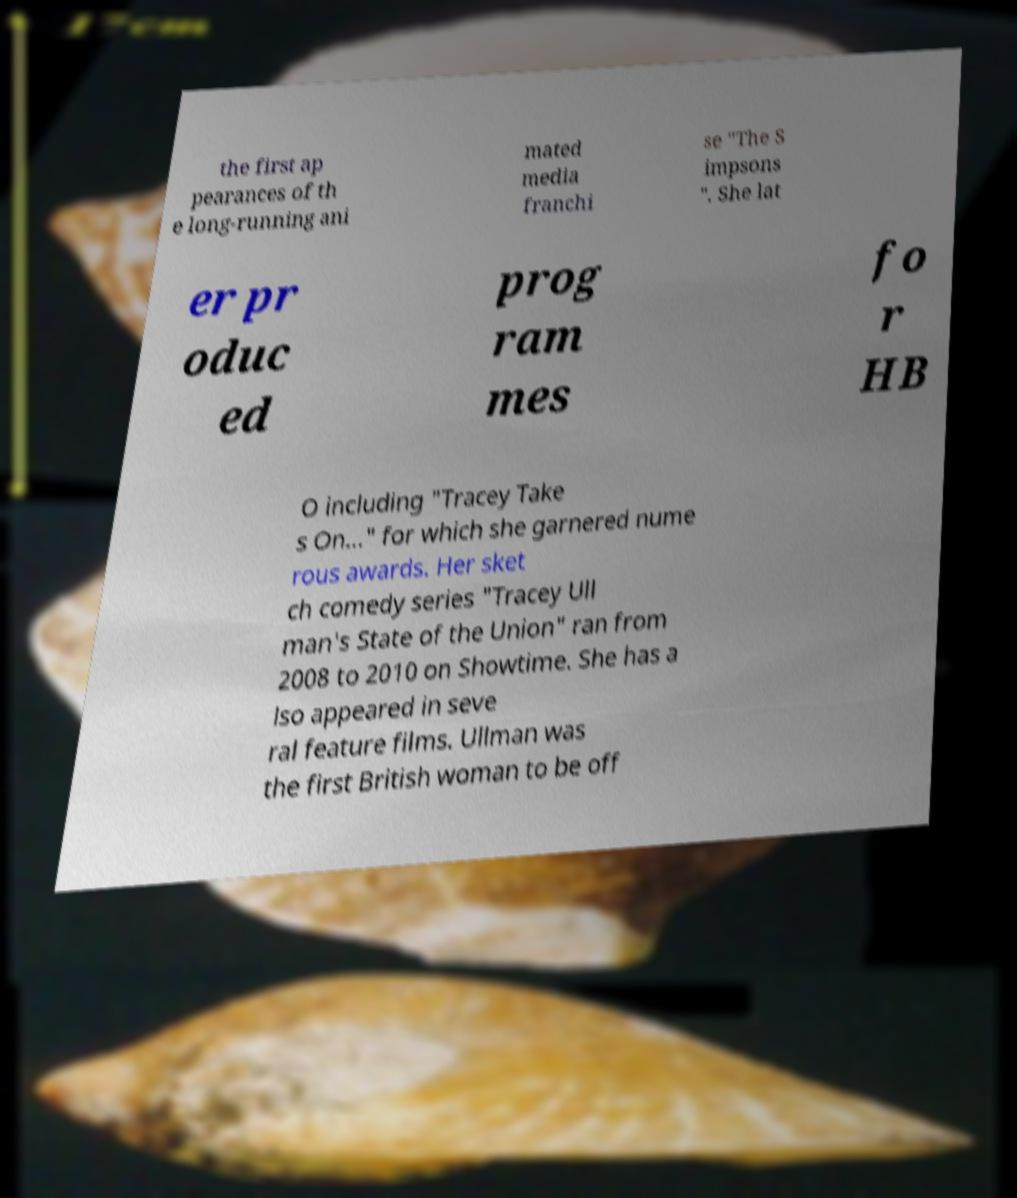What messages or text are displayed in this image? I need them in a readable, typed format. the first ap pearances of th e long-running ani mated media franchi se "The S impsons ". She lat er pr oduc ed prog ram mes fo r HB O including "Tracey Take s On..." for which she garnered nume rous awards. Her sket ch comedy series "Tracey Ull man's State of the Union" ran from 2008 to 2010 on Showtime. She has a lso appeared in seve ral feature films. Ullman was the first British woman to be off 